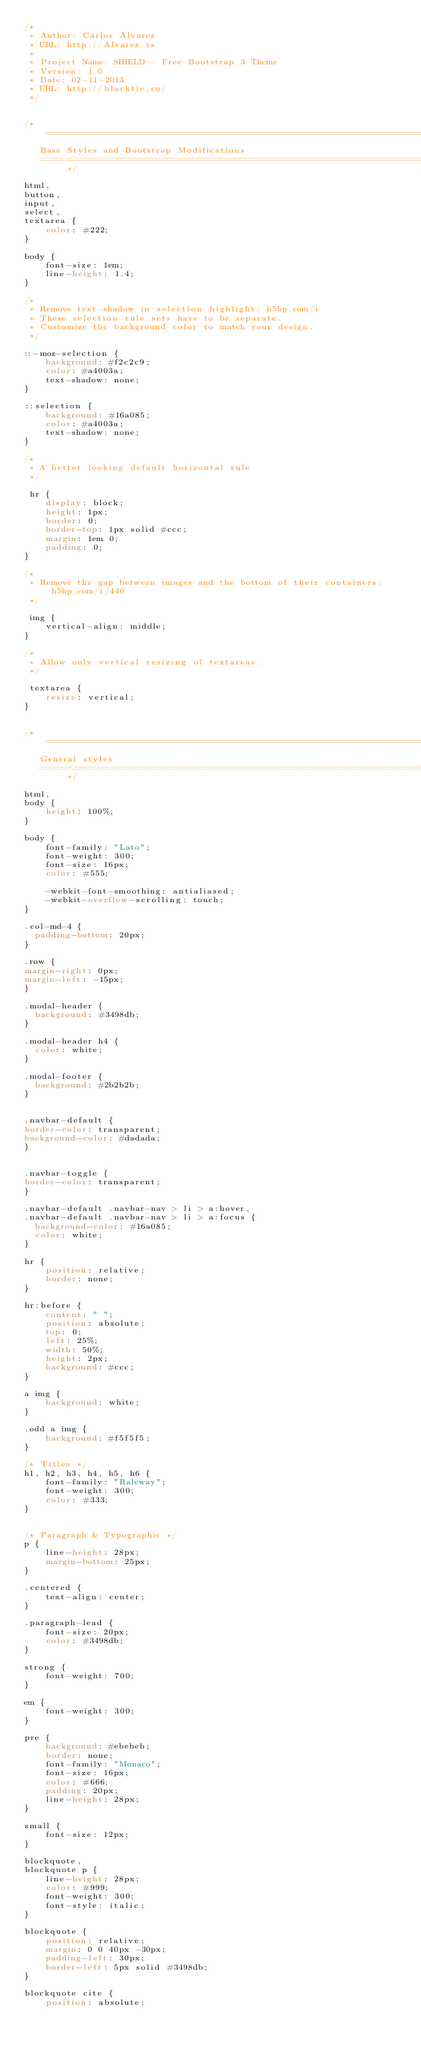Convert code to text. <code><loc_0><loc_0><loc_500><loc_500><_CSS_>/*
 * Author: Carlos Alvarez
 * URL: http://Alvarez.is
 *
 * Project Name: SHIELD - Free Bootstrap 3 Theme
 * Version: 1.0
 * Date: 02-11-2013
 * URL: http://blacktie.co/
 */


/* ==========================================================================
   Base Styles and Bootstrap Modifications
   ========================================================================== */

html,
button,
input,
select,
textarea {
    color: #222;
}

body {
    font-size: 1em;
    line-height: 1.4;
}

/*
 * Remove text-shadow in selection highlight: h5bp.com/i
 * These selection rule sets have to be separate.
 * Customize the background color to match your design.
 */

::-moz-selection {
    background: #f2c2c9;
    color: #a4003a;
    text-shadow: none;
}

::selection {
    background: #16a085;
    color: #a4003a;
    text-shadow: none;
}

/*
 * A better looking default horizontal rule
 */

 hr {
    display: block;
    height: 1px;
    border: 0;
    border-top: 1px solid #ccc;
    margin: 1em 0;
    padding: 0;
}

/*
 * Remove the gap between images and the bottom of their containers: h5bp.com/i/440
 */

 img {
    vertical-align: middle;
}

/*
 * Allow only vertical resizing of textareas.
 */

 textarea {
    resize: vertical;
}


/* ==========================================================================
   General styles
   ========================================================================== */

html,
body {
    height: 100%;
}

body {
    font-family: "Lato";
    font-weight: 300;
    font-size: 16px;
    color: #555;

    -webkit-font-smoothing: antialiased;
    -webkit-overflow-scrolling: touch;
}

.col-md-4 {
	padding-bottom: 20px;
}

.row {
margin-right: 0px;
margin-left: -15px;
}

.modal-header {
	background: #3498db;
}

.modal-header h4 {
	color: white;
}

.modal-footer {
	background: #2b2b2b;
}


.navbar-default {
border-color: transparent;
background-color: #dadada;
}


.navbar-toggle {
border-color: transparent;
}

.navbar-default .navbar-nav > li > a:hover,
.navbar-default .navbar-nav > li > a:focus {
	background-color: #16a085;
	color: white;
}

hr {
    position: relative;
    border: none;
}

hr:before {
    content: " ";
    position: absolute;
    top: 0;
    left: 25%;
    width: 50%;
    height: 2px;
    background: #ccc;
}

a img {
    background: white;
}

.odd a img {
    background: #f5f5f5;
}

/* Titles */
h1, h2, h3, h4, h5, h6 {
    font-family: "Raleway";
    font-weight: 300;
    color: #333;
}


/* Paragraph & Typographic */
p {
    line-height: 28px;
    margin-bottom: 25px;
}

.centered {
    text-align: center;
}

.paragraph-lead {
    font-size: 20px;
    color: #3498db;
}

strong {
    font-weight: 700;
}

em {
    font-weight: 300;
}

pre {
    background: #ebebeb;
    border: none;
    font-family: "Monaco";
    font-size: 16px;
    color: #666;
    padding: 20px;
    line-height: 28px;
}

small {
    font-size: 12px;
}

blockquote,
blockquote p {
    line-height: 28px;
    color: #999;
    font-weight: 300;
    font-style: italic;
}

blockquote {
    position: relative;
    margin: 0 0 40px -30px;
    padding-left: 30px;
    border-left: 5px solid #3498db;
}

blockquote cite {
    position: absolute;</code> 